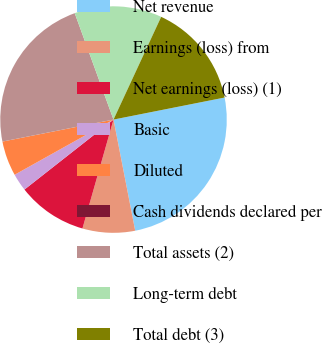Convert chart to OTSL. <chart><loc_0><loc_0><loc_500><loc_500><pie_chart><fcel>Net revenue<fcel>Earnings (loss) from<fcel>Net earnings (loss) (1)<fcel>Basic<fcel>Diluted<fcel>Cash dividends declared per<fcel>Total assets (2)<fcel>Long-term debt<fcel>Total debt (3)<nl><fcel>25.05%<fcel>7.49%<fcel>9.98%<fcel>2.5%<fcel>4.99%<fcel>0.0%<fcel>22.55%<fcel>12.48%<fcel>14.97%<nl></chart> 